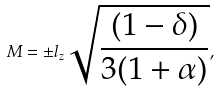Convert formula to latex. <formula><loc_0><loc_0><loc_500><loc_500>M = \pm l _ { z } \sqrt { \frac { ( 1 - \delta ) } { 3 ( 1 + \alpha ) } } ,</formula> 